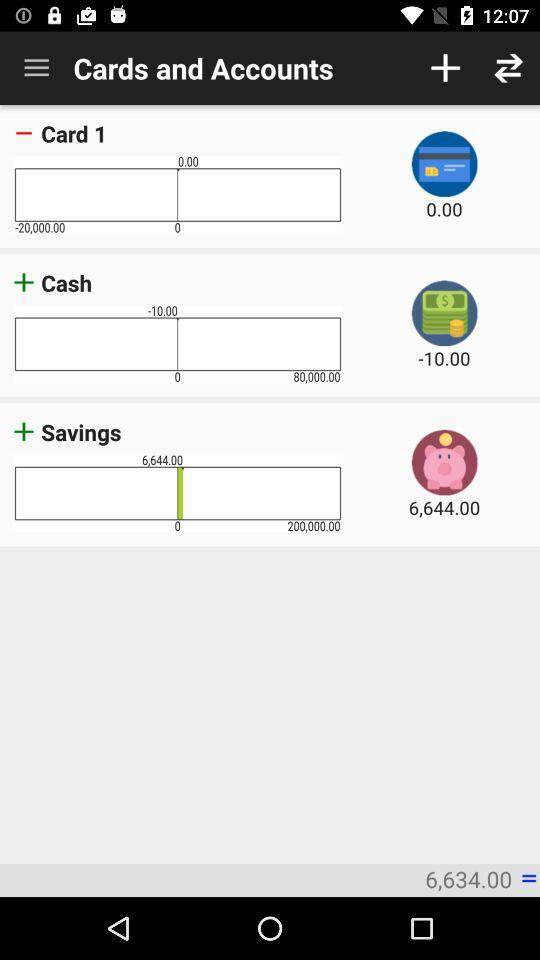What is the total amount of money in my accounts?
Answer the question using a single word or phrase. 6,634.00 